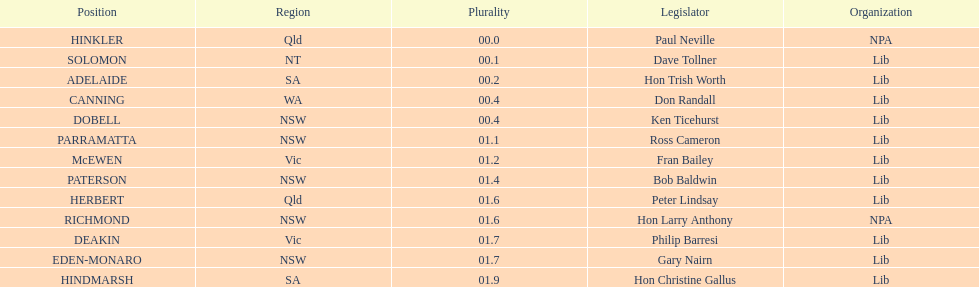Was fran bailey from vic or wa? Vic. 